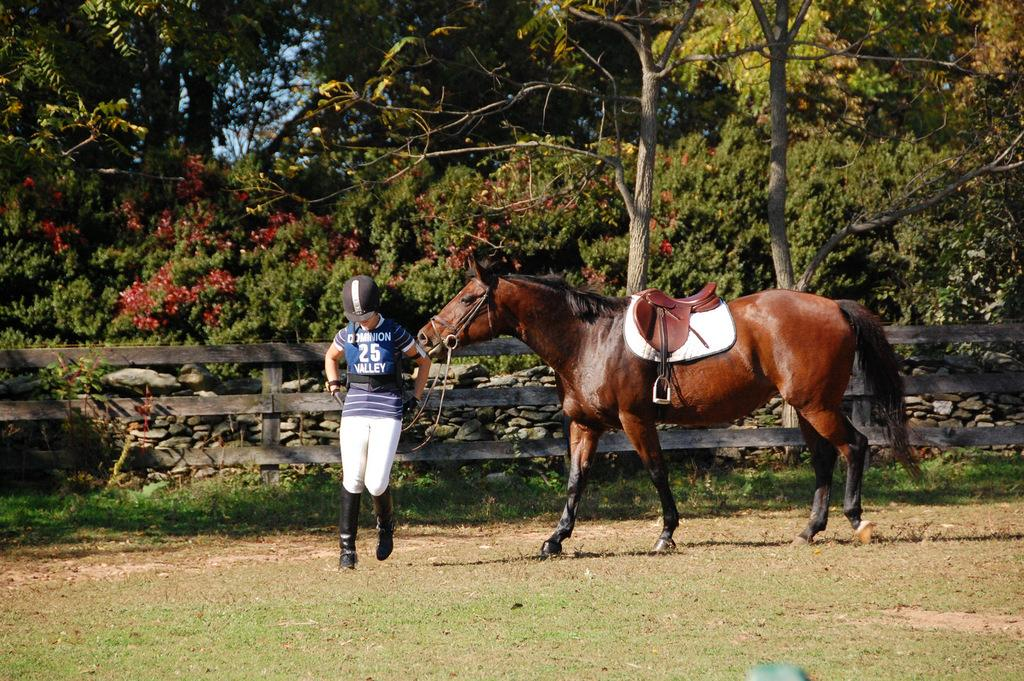What animal is present in the image? There is a horse in the image. What is the position of the person in the image? There is a person on the ground in the image. What can be seen in the background of the image? There is a fence, stones, trees, and the sky visible in the background of the image. What type of leather is being used to make the part of the horse's saddle in the image? There is no mention of a saddle or leather in the image, as it only features a horse and a person on the ground. 